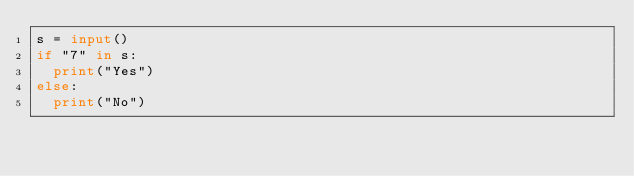<code> <loc_0><loc_0><loc_500><loc_500><_Python_>s = input()
if "7" in s:
  print("Yes")
else:
  print("No")</code> 